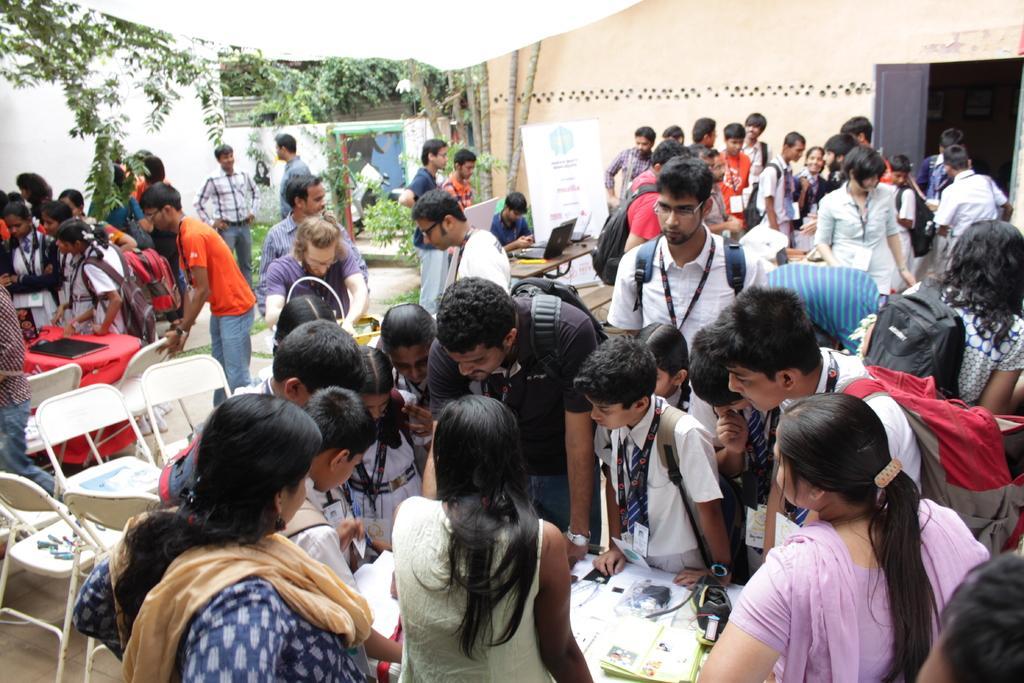In one or two sentences, can you explain what this image depicts? There are so many people standing around the table and watching at the papers on table and there are other people looking at other tables and behind that there is a building and some trees. 